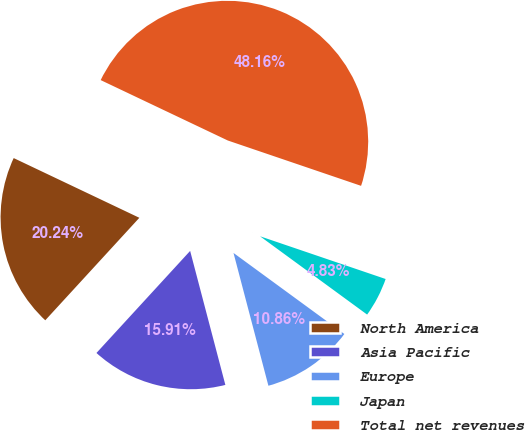<chart> <loc_0><loc_0><loc_500><loc_500><pie_chart><fcel>North America<fcel>Asia Pacific<fcel>Europe<fcel>Japan<fcel>Total net revenues<nl><fcel>20.24%<fcel>15.91%<fcel>10.86%<fcel>4.83%<fcel>48.16%<nl></chart> 